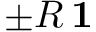Convert formula to latex. <formula><loc_0><loc_0><loc_500><loc_500>\pm R \, 1</formula> 